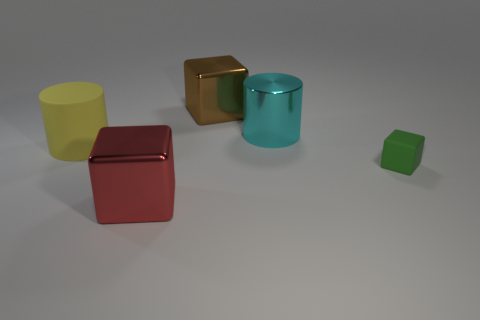Subtract all rubber cubes. How many cubes are left? 2 Subtract 1 blocks. How many blocks are left? 2 Add 3 big blue things. How many big blue things exist? 3 Add 4 purple balls. How many objects exist? 9 Subtract all yellow cylinders. How many cylinders are left? 1 Subtract 0 yellow spheres. How many objects are left? 5 Subtract all blocks. How many objects are left? 2 Subtract all red blocks. Subtract all yellow spheres. How many blocks are left? 2 Subtract all gray cylinders. How many green blocks are left? 1 Subtract all large yellow matte cylinders. Subtract all metal cylinders. How many objects are left? 3 